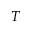Convert formula to latex. <formula><loc_0><loc_0><loc_500><loc_500>T</formula> 